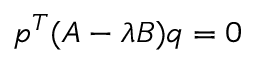Convert formula to latex. <formula><loc_0><loc_0><loc_500><loc_500>p ^ { T } ( A - \lambda B ) q = 0</formula> 